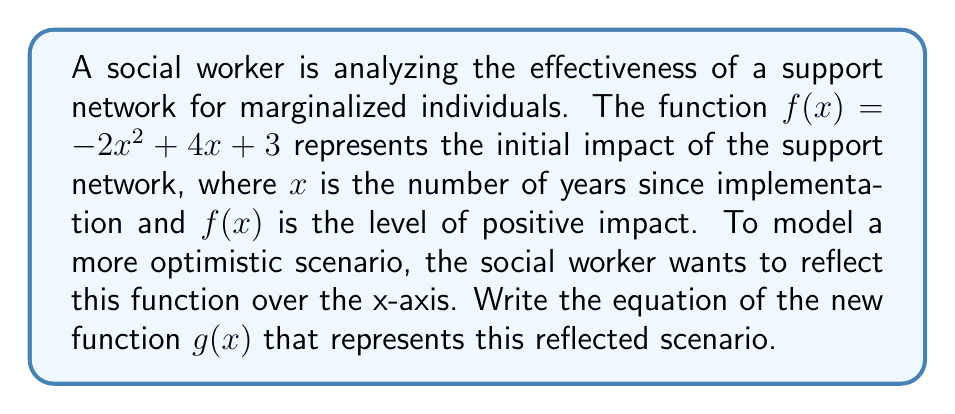What is the answer to this math problem? To reflect a function over the x-axis, we need to negate the entire function. This means multiplying the original function by -1. Here's how we do it step-by-step:

1. Start with the original function: $f(x) = -2x^2 + 4x + 3$

2. Multiply the entire function by -1:
   $g(x) = -1 \cdot (-2x^2 + 4x + 3)$

3. Distribute the negative sign:
   $g(x) = 2x^2 - 4x - 3$

The resulting function $g(x) = 2x^2 - 4x - 3$ represents the reflected scenario, where the positive impact is now modeled as an upward-opening parabola. This reflection suggests a more optimistic long-term outlook for the support network's effectiveness.
Answer: $g(x) = 2x^2 - 4x - 3$ 